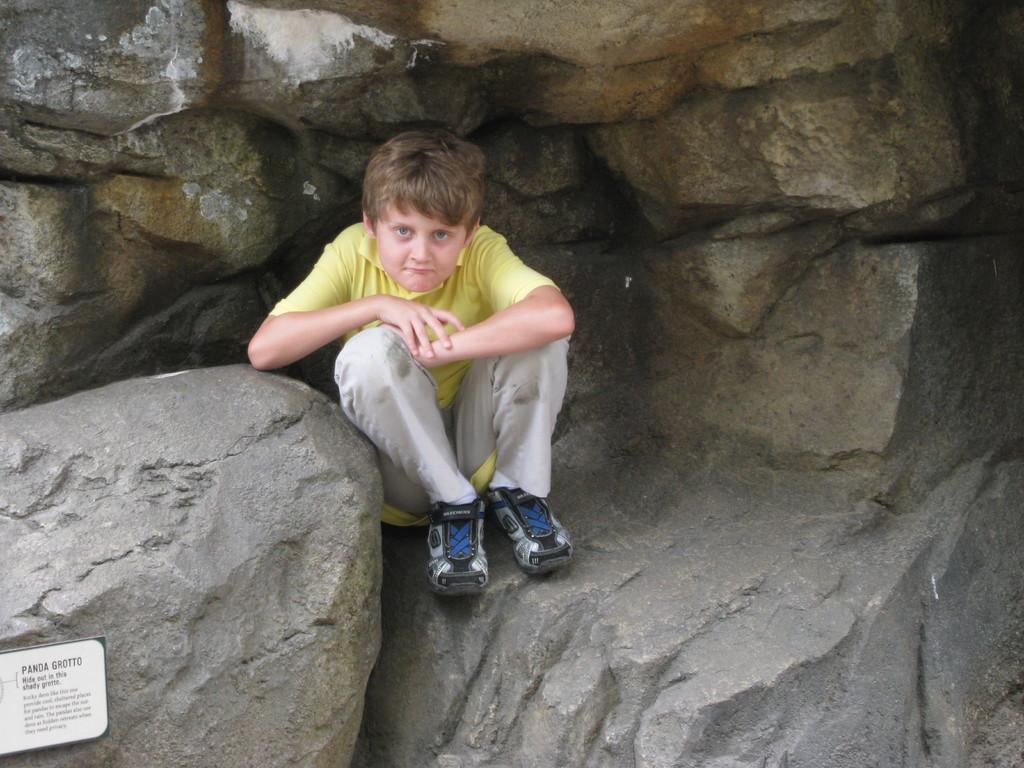In one or two sentences, can you explain what this image depicts? In the background portion of the picture we can see the mountains. In this picture we can see a boy wearing a yellow t-shirt. He is sitting on a rock surface. In the bottom left corner of the picture we can see a board and some information. 